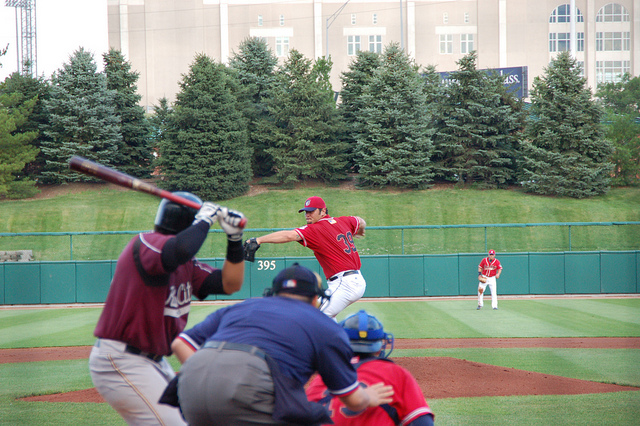Please transcribe the text information in this image. lass 395 39 